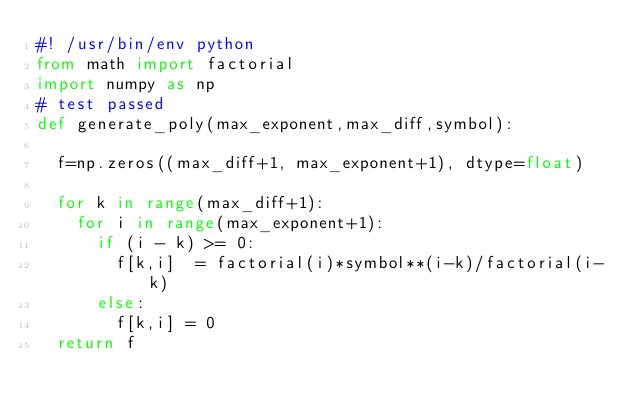<code> <loc_0><loc_0><loc_500><loc_500><_Python_>#! /usr/bin/env python
from math import factorial
import numpy as np
# test passed
def generate_poly(max_exponent,max_diff,symbol):
	
	f=np.zeros((max_diff+1, max_exponent+1), dtype=float)
	
	for k in range(max_diff+1):
		for i in range(max_exponent+1):
			if (i - k) >= 0:
				f[k,i]  = factorial(i)*symbol**(i-k)/factorial(i-k)
			else:
				f[k,i] = 0
	return f</code> 